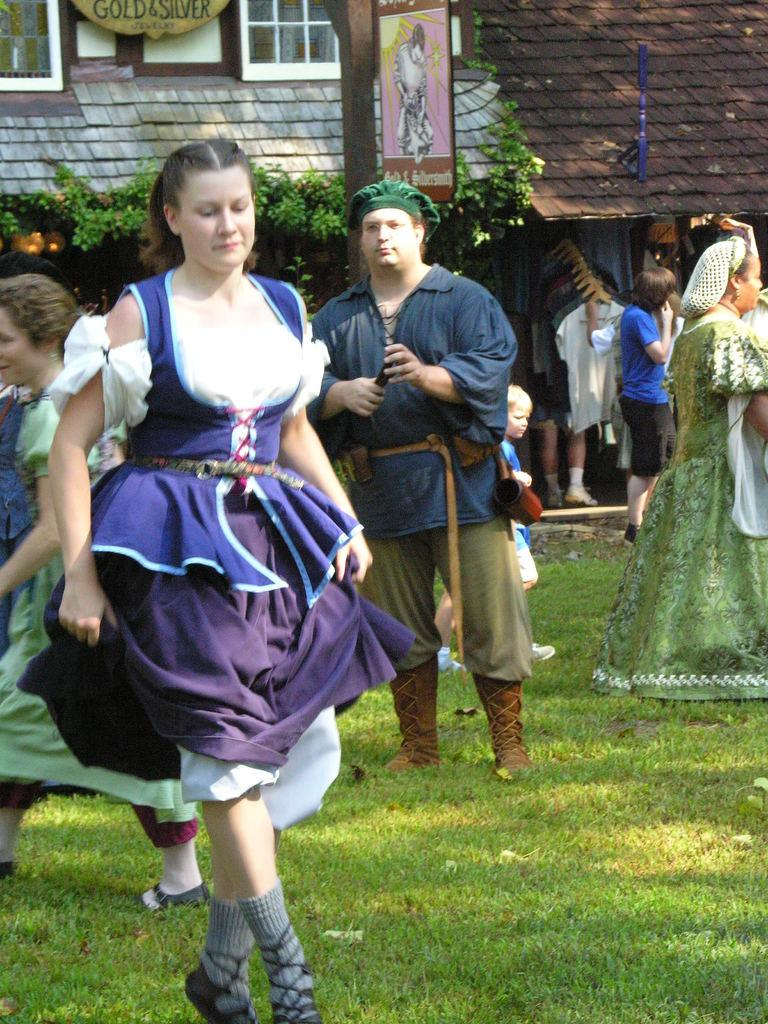What are the people in the image doing? The group of people is standing on the ground in the image. What type of vegetation can be seen in the image? There is grass in the image. What type of structure is visible in the image? There is a house in the image. What part of the house is visible in the image? There is a window in the image. What can be seen inside the house through the window? A light is visible in the image. What type of crime is being committed by the beetle in the image? There is no beetle present in the image, and therefore no crime can be committed by a beetle. 